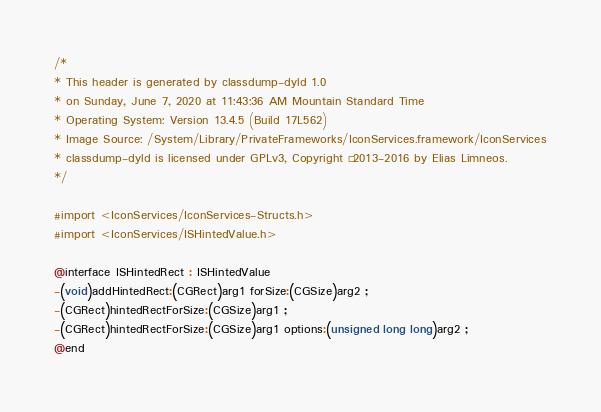Convert code to text. <code><loc_0><loc_0><loc_500><loc_500><_C_>/*
* This header is generated by classdump-dyld 1.0
* on Sunday, June 7, 2020 at 11:43:36 AM Mountain Standard Time
* Operating System: Version 13.4.5 (Build 17L562)
* Image Source: /System/Library/PrivateFrameworks/IconServices.framework/IconServices
* classdump-dyld is licensed under GPLv3, Copyright © 2013-2016 by Elias Limneos.
*/

#import <IconServices/IconServices-Structs.h>
#import <IconServices/ISHintedValue.h>

@interface ISHintedRect : ISHintedValue
-(void)addHintedRect:(CGRect)arg1 forSize:(CGSize)arg2 ;
-(CGRect)hintedRectForSize:(CGSize)arg1 ;
-(CGRect)hintedRectForSize:(CGSize)arg1 options:(unsigned long long)arg2 ;
@end

</code> 